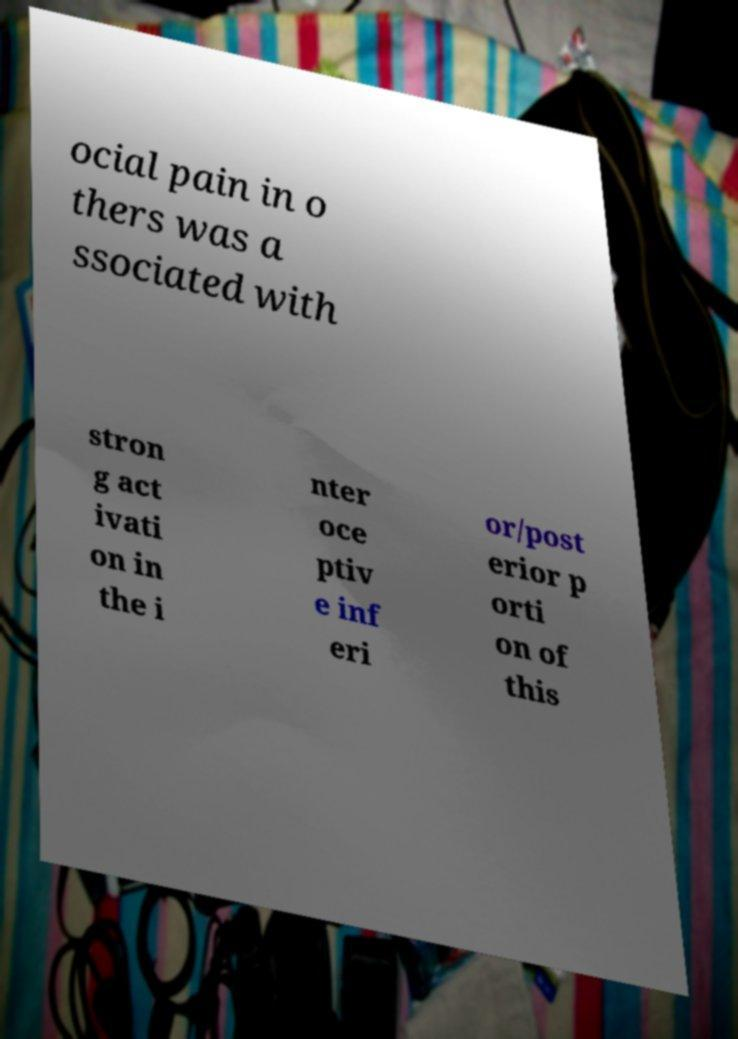There's text embedded in this image that I need extracted. Can you transcribe it verbatim? ocial pain in o thers was a ssociated with stron g act ivati on in the i nter oce ptiv e inf eri or/post erior p orti on of this 